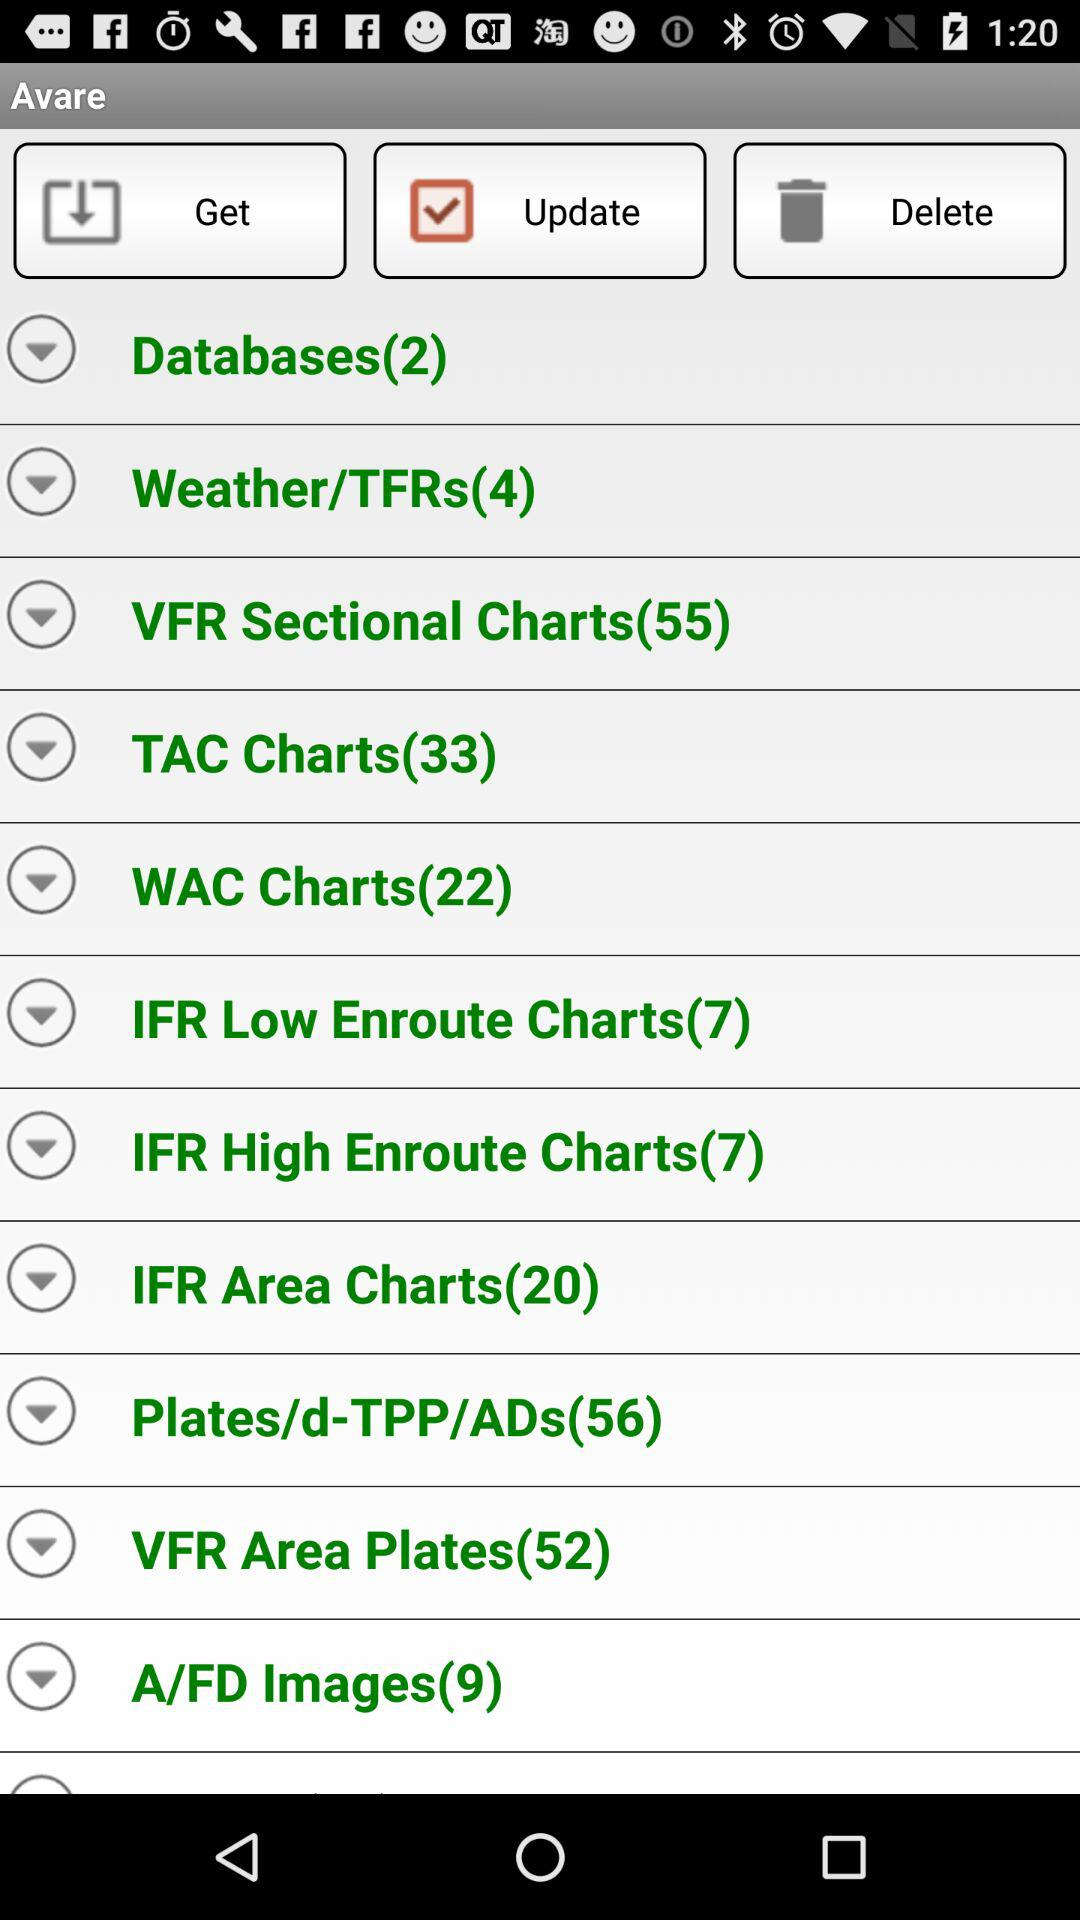How many "TAC Charts" are there? There are 33 TAC charts. 